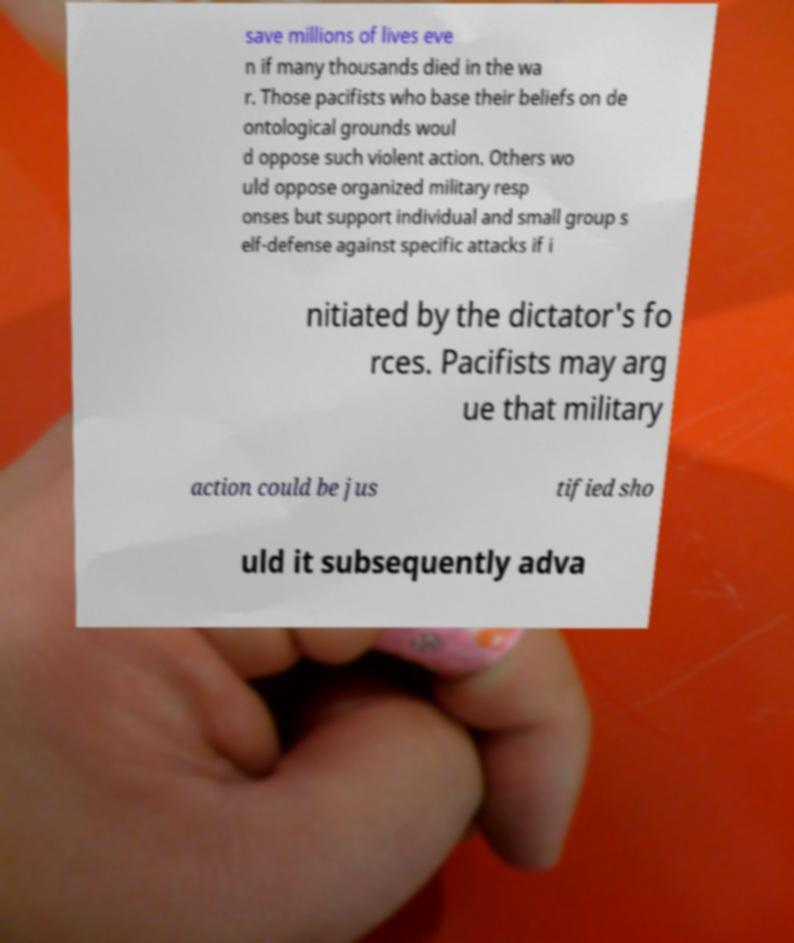For documentation purposes, I need the text within this image transcribed. Could you provide that? save millions of lives eve n if many thousands died in the wa r. Those pacifists who base their beliefs on de ontological grounds woul d oppose such violent action. Others wo uld oppose organized military resp onses but support individual and small group s elf-defense against specific attacks if i nitiated by the dictator's fo rces. Pacifists may arg ue that military action could be jus tified sho uld it subsequently adva 